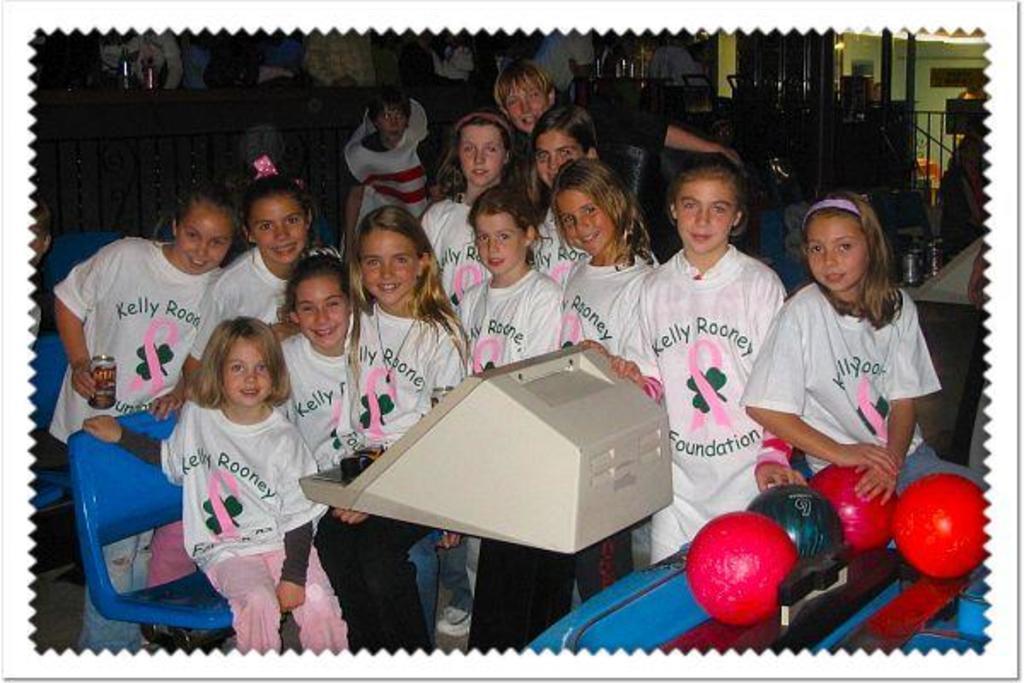Could you give a brief overview of what you see in this image? In this picture we can see a group of girls were some are sitting on chairs and some are standing and smiling, balls, machine and in the background we can see some objects. 